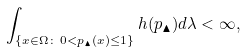<formula> <loc_0><loc_0><loc_500><loc_500>\int _ { \left \{ x \in \Omega \colon \, 0 < p _ { \blacktriangle } ( x ) \leq 1 \right \} } h ( p _ { \blacktriangle } ) d \lambda < \infty ,</formula> 